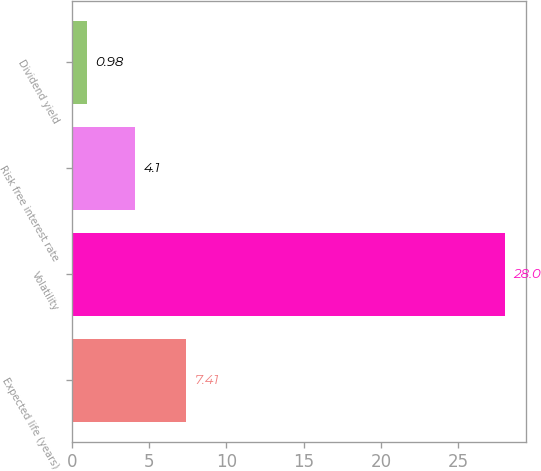Convert chart to OTSL. <chart><loc_0><loc_0><loc_500><loc_500><bar_chart><fcel>Expected life (years)<fcel>Volatility<fcel>Risk free interest rate<fcel>Dividend yield<nl><fcel>7.41<fcel>28<fcel>4.1<fcel>0.98<nl></chart> 